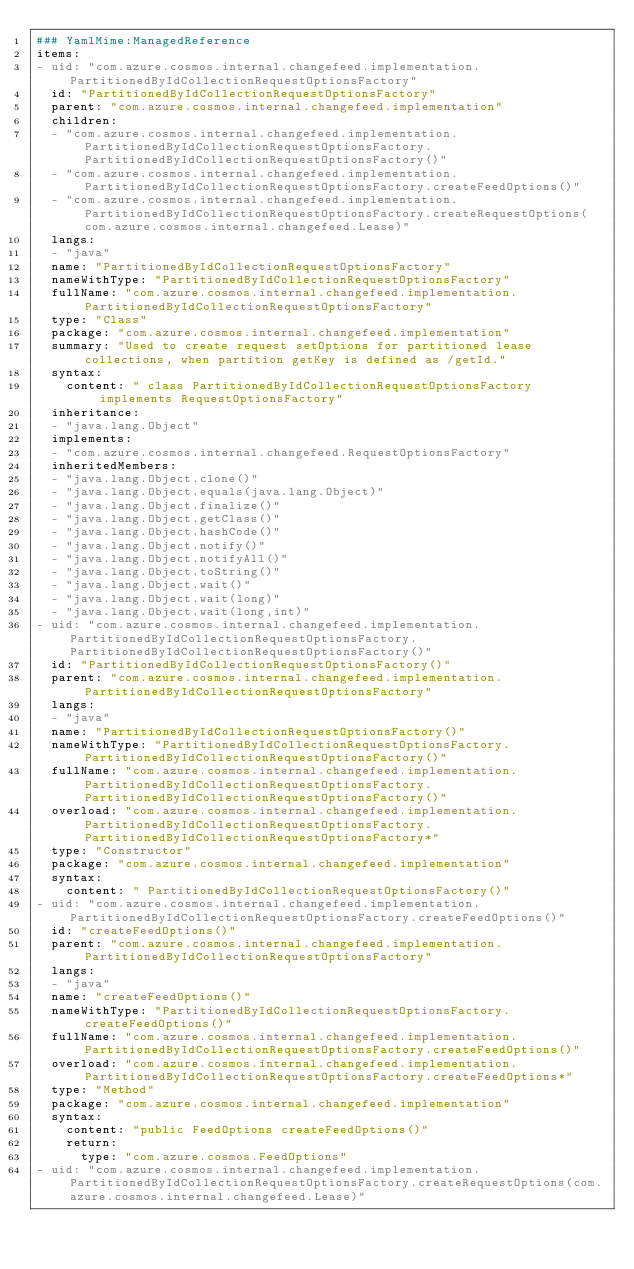Convert code to text. <code><loc_0><loc_0><loc_500><loc_500><_YAML_>### YamlMime:ManagedReference
items:
- uid: "com.azure.cosmos.internal.changefeed.implementation.PartitionedByIdCollectionRequestOptionsFactory"
  id: "PartitionedByIdCollectionRequestOptionsFactory"
  parent: "com.azure.cosmos.internal.changefeed.implementation"
  children:
  - "com.azure.cosmos.internal.changefeed.implementation.PartitionedByIdCollectionRequestOptionsFactory.PartitionedByIdCollectionRequestOptionsFactory()"
  - "com.azure.cosmos.internal.changefeed.implementation.PartitionedByIdCollectionRequestOptionsFactory.createFeedOptions()"
  - "com.azure.cosmos.internal.changefeed.implementation.PartitionedByIdCollectionRequestOptionsFactory.createRequestOptions(com.azure.cosmos.internal.changefeed.Lease)"
  langs:
  - "java"
  name: "PartitionedByIdCollectionRequestOptionsFactory"
  nameWithType: "PartitionedByIdCollectionRequestOptionsFactory"
  fullName: "com.azure.cosmos.internal.changefeed.implementation.PartitionedByIdCollectionRequestOptionsFactory"
  type: "Class"
  package: "com.azure.cosmos.internal.changefeed.implementation"
  summary: "Used to create request setOptions for partitioned lease collections, when partition getKey is defined as /getId."
  syntax:
    content: " class PartitionedByIdCollectionRequestOptionsFactory implements RequestOptionsFactory"
  inheritance:
  - "java.lang.Object"
  implements:
  - "com.azure.cosmos.internal.changefeed.RequestOptionsFactory"
  inheritedMembers:
  - "java.lang.Object.clone()"
  - "java.lang.Object.equals(java.lang.Object)"
  - "java.lang.Object.finalize()"
  - "java.lang.Object.getClass()"
  - "java.lang.Object.hashCode()"
  - "java.lang.Object.notify()"
  - "java.lang.Object.notifyAll()"
  - "java.lang.Object.toString()"
  - "java.lang.Object.wait()"
  - "java.lang.Object.wait(long)"
  - "java.lang.Object.wait(long,int)"
- uid: "com.azure.cosmos.internal.changefeed.implementation.PartitionedByIdCollectionRequestOptionsFactory.PartitionedByIdCollectionRequestOptionsFactory()"
  id: "PartitionedByIdCollectionRequestOptionsFactory()"
  parent: "com.azure.cosmos.internal.changefeed.implementation.PartitionedByIdCollectionRequestOptionsFactory"
  langs:
  - "java"
  name: "PartitionedByIdCollectionRequestOptionsFactory()"
  nameWithType: "PartitionedByIdCollectionRequestOptionsFactory.PartitionedByIdCollectionRequestOptionsFactory()"
  fullName: "com.azure.cosmos.internal.changefeed.implementation.PartitionedByIdCollectionRequestOptionsFactory.PartitionedByIdCollectionRequestOptionsFactory()"
  overload: "com.azure.cosmos.internal.changefeed.implementation.PartitionedByIdCollectionRequestOptionsFactory.PartitionedByIdCollectionRequestOptionsFactory*"
  type: "Constructor"
  package: "com.azure.cosmos.internal.changefeed.implementation"
  syntax:
    content: " PartitionedByIdCollectionRequestOptionsFactory()"
- uid: "com.azure.cosmos.internal.changefeed.implementation.PartitionedByIdCollectionRequestOptionsFactory.createFeedOptions()"
  id: "createFeedOptions()"
  parent: "com.azure.cosmos.internal.changefeed.implementation.PartitionedByIdCollectionRequestOptionsFactory"
  langs:
  - "java"
  name: "createFeedOptions()"
  nameWithType: "PartitionedByIdCollectionRequestOptionsFactory.createFeedOptions()"
  fullName: "com.azure.cosmos.internal.changefeed.implementation.PartitionedByIdCollectionRequestOptionsFactory.createFeedOptions()"
  overload: "com.azure.cosmos.internal.changefeed.implementation.PartitionedByIdCollectionRequestOptionsFactory.createFeedOptions*"
  type: "Method"
  package: "com.azure.cosmos.internal.changefeed.implementation"
  syntax:
    content: "public FeedOptions createFeedOptions()"
    return:
      type: "com.azure.cosmos.FeedOptions"
- uid: "com.azure.cosmos.internal.changefeed.implementation.PartitionedByIdCollectionRequestOptionsFactory.createRequestOptions(com.azure.cosmos.internal.changefeed.Lease)"</code> 